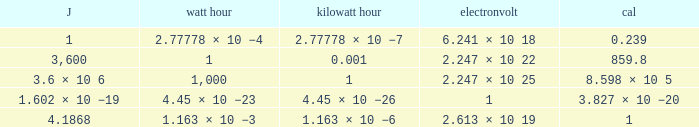Would you mind parsing the complete table? {'header': ['J', 'watt hour', 'kilowatt hour', 'electronvolt', 'cal'], 'rows': [['1', '2.77778 × 10 −4', '2.77778 × 10 −7', '6.241 × 10 18', '0.239'], ['3,600', '1', '0.001', '2.247 × 10 22', '859.8'], ['3.6 × 10 6', '1,000', '1', '2.247 × 10 25', '8.598 × 10 5'], ['1.602 × 10 −19', '4.45 × 10 −23', '4.45 × 10 −26', '1', '3.827 × 10 −20'], ['4.1868', '1.163 × 10 −3', '1.163 × 10 −6', '2.613 × 10 19', '1']]} How many electronvolts is 3,600 joules? 2.247 × 10 22. 